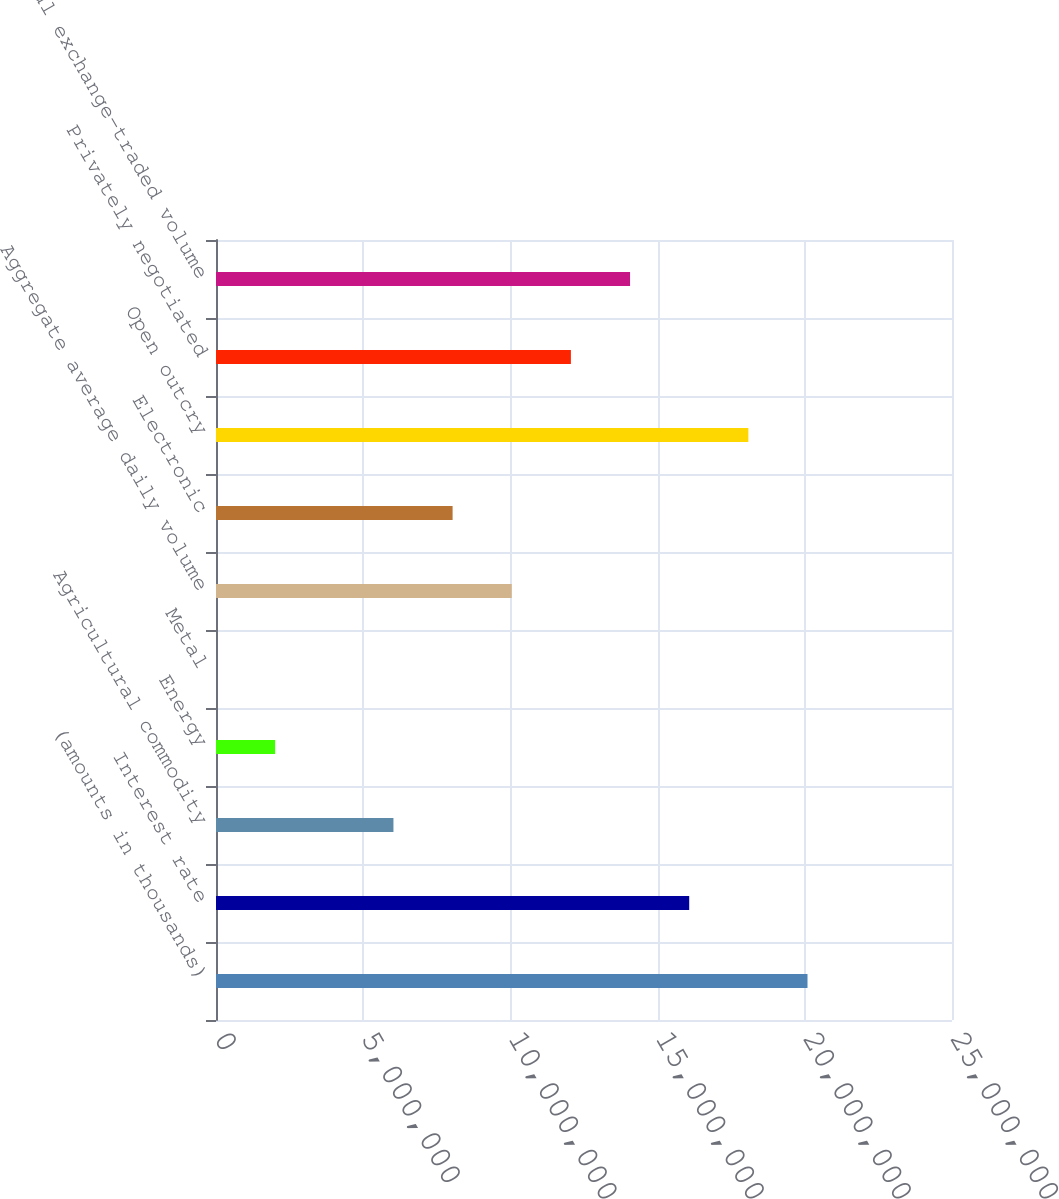Convert chart to OTSL. <chart><loc_0><loc_0><loc_500><loc_500><bar_chart><fcel>(amounts in thousands)<fcel>Interest rate<fcel>Agricultural commodity<fcel>Energy<fcel>Metal<fcel>Aggregate average daily volume<fcel>Electronic<fcel>Open outcry<fcel>Privately negotiated<fcel>Total exchange-traded volume<nl><fcel>2.0092e+07<fcel>1.60736e+07<fcel>6.02761e+06<fcel>2.00921e+06<fcel>8<fcel>1.0046e+07<fcel>8.03681e+06<fcel>1.80828e+07<fcel>1.20552e+07<fcel>1.40644e+07<nl></chart> 